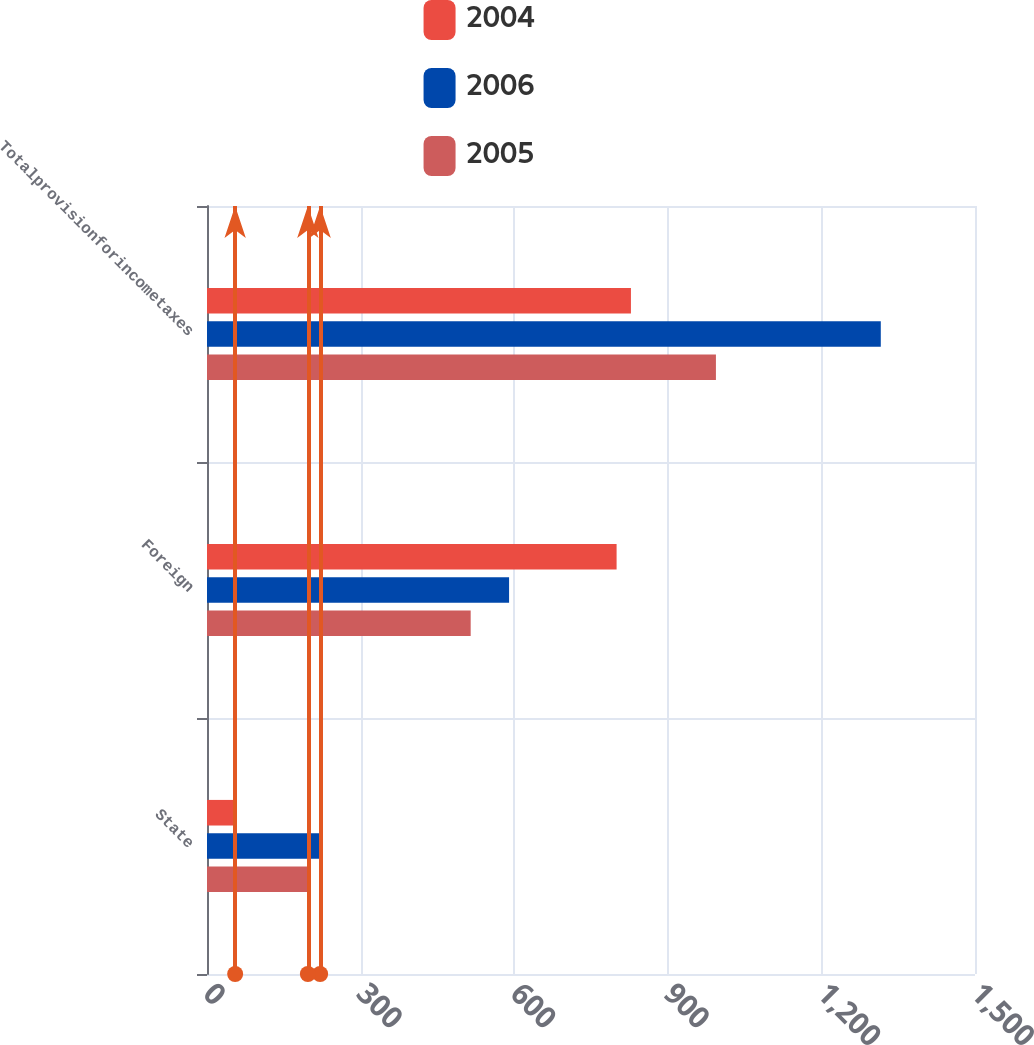Convert chart. <chart><loc_0><loc_0><loc_500><loc_500><stacked_bar_chart><ecel><fcel>State<fcel>Foreign<fcel>Totalprovisionforincometaxes<nl><fcel>2004<fcel>55<fcel>800<fcel>828<nl><fcel>2006<fcel>221<fcel>590<fcel>1316<nl><fcel>2005<fcel>197<fcel>515<fcel>994<nl></chart> 